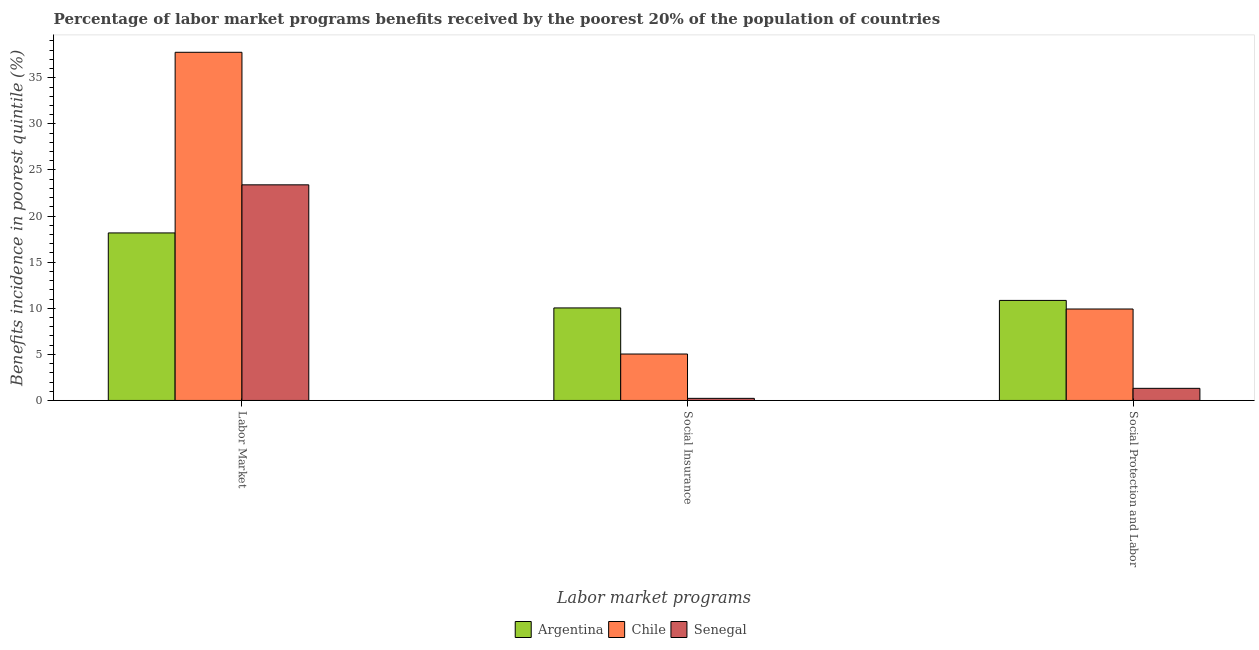How many groups of bars are there?
Provide a succinct answer. 3. Are the number of bars per tick equal to the number of legend labels?
Offer a terse response. Yes. Are the number of bars on each tick of the X-axis equal?
Offer a terse response. Yes. What is the label of the 2nd group of bars from the left?
Offer a very short reply. Social Insurance. What is the percentage of benefits received due to social protection programs in Senegal?
Keep it short and to the point. 1.31. Across all countries, what is the maximum percentage of benefits received due to social insurance programs?
Give a very brief answer. 10.04. Across all countries, what is the minimum percentage of benefits received due to social insurance programs?
Offer a terse response. 0.23. In which country was the percentage of benefits received due to social protection programs minimum?
Give a very brief answer. Senegal. What is the total percentage of benefits received due to labor market programs in the graph?
Make the answer very short. 79.33. What is the difference between the percentage of benefits received due to labor market programs in Senegal and that in Chile?
Your answer should be compact. -14.38. What is the difference between the percentage of benefits received due to labor market programs in Chile and the percentage of benefits received due to social protection programs in Senegal?
Make the answer very short. 36.45. What is the average percentage of benefits received due to social insurance programs per country?
Give a very brief answer. 5.1. What is the difference between the percentage of benefits received due to social protection programs and percentage of benefits received due to labor market programs in Argentina?
Provide a succinct answer. -7.32. What is the ratio of the percentage of benefits received due to social insurance programs in Senegal to that in Chile?
Your answer should be compact. 0.05. Is the percentage of benefits received due to social insurance programs in Senegal less than that in Argentina?
Provide a short and direct response. Yes. Is the difference between the percentage of benefits received due to social protection programs in Chile and Senegal greater than the difference between the percentage of benefits received due to labor market programs in Chile and Senegal?
Your answer should be very brief. No. What is the difference between the highest and the second highest percentage of benefits received due to social protection programs?
Your answer should be compact. 0.93. What is the difference between the highest and the lowest percentage of benefits received due to social insurance programs?
Offer a very short reply. 9.81. In how many countries, is the percentage of benefits received due to social protection programs greater than the average percentage of benefits received due to social protection programs taken over all countries?
Your answer should be very brief. 2. What does the 2nd bar from the left in Social Insurance represents?
Offer a very short reply. Chile. What does the 2nd bar from the right in Labor Market represents?
Offer a very short reply. Chile. Is it the case that in every country, the sum of the percentage of benefits received due to labor market programs and percentage of benefits received due to social insurance programs is greater than the percentage of benefits received due to social protection programs?
Your response must be concise. Yes. Are all the bars in the graph horizontal?
Provide a succinct answer. No. What is the difference between two consecutive major ticks on the Y-axis?
Your response must be concise. 5. Are the values on the major ticks of Y-axis written in scientific E-notation?
Ensure brevity in your answer.  No. Does the graph contain any zero values?
Ensure brevity in your answer.  No. Does the graph contain grids?
Provide a short and direct response. No. How many legend labels are there?
Give a very brief answer. 3. How are the legend labels stacked?
Your response must be concise. Horizontal. What is the title of the graph?
Give a very brief answer. Percentage of labor market programs benefits received by the poorest 20% of the population of countries. What is the label or title of the X-axis?
Offer a terse response. Labor market programs. What is the label or title of the Y-axis?
Keep it short and to the point. Benefits incidence in poorest quintile (%). What is the Benefits incidence in poorest quintile (%) of Argentina in Labor Market?
Offer a terse response. 18.17. What is the Benefits incidence in poorest quintile (%) of Chile in Labor Market?
Provide a succinct answer. 37.77. What is the Benefits incidence in poorest quintile (%) in Senegal in Labor Market?
Offer a very short reply. 23.39. What is the Benefits incidence in poorest quintile (%) in Argentina in Social Insurance?
Keep it short and to the point. 10.04. What is the Benefits incidence in poorest quintile (%) of Chile in Social Insurance?
Provide a short and direct response. 5.04. What is the Benefits incidence in poorest quintile (%) in Senegal in Social Insurance?
Keep it short and to the point. 0.23. What is the Benefits incidence in poorest quintile (%) in Argentina in Social Protection and Labor?
Provide a short and direct response. 10.85. What is the Benefits incidence in poorest quintile (%) in Chile in Social Protection and Labor?
Offer a terse response. 9.92. What is the Benefits incidence in poorest quintile (%) in Senegal in Social Protection and Labor?
Give a very brief answer. 1.31. Across all Labor market programs, what is the maximum Benefits incidence in poorest quintile (%) of Argentina?
Your answer should be compact. 18.17. Across all Labor market programs, what is the maximum Benefits incidence in poorest quintile (%) of Chile?
Provide a short and direct response. 37.77. Across all Labor market programs, what is the maximum Benefits incidence in poorest quintile (%) in Senegal?
Offer a very short reply. 23.39. Across all Labor market programs, what is the minimum Benefits incidence in poorest quintile (%) in Argentina?
Ensure brevity in your answer.  10.04. Across all Labor market programs, what is the minimum Benefits incidence in poorest quintile (%) in Chile?
Ensure brevity in your answer.  5.04. Across all Labor market programs, what is the minimum Benefits incidence in poorest quintile (%) in Senegal?
Offer a very short reply. 0.23. What is the total Benefits incidence in poorest quintile (%) of Argentina in the graph?
Give a very brief answer. 39.06. What is the total Benefits incidence in poorest quintile (%) in Chile in the graph?
Your answer should be very brief. 52.72. What is the total Benefits incidence in poorest quintile (%) of Senegal in the graph?
Your answer should be very brief. 24.93. What is the difference between the Benefits incidence in poorest quintile (%) of Argentina in Labor Market and that in Social Insurance?
Make the answer very short. 8.14. What is the difference between the Benefits incidence in poorest quintile (%) in Chile in Labor Market and that in Social Insurance?
Your response must be concise. 32.73. What is the difference between the Benefits incidence in poorest quintile (%) in Senegal in Labor Market and that in Social Insurance?
Keep it short and to the point. 23.16. What is the difference between the Benefits incidence in poorest quintile (%) of Argentina in Labor Market and that in Social Protection and Labor?
Offer a terse response. 7.32. What is the difference between the Benefits incidence in poorest quintile (%) in Chile in Labor Market and that in Social Protection and Labor?
Your answer should be compact. 27.85. What is the difference between the Benefits incidence in poorest quintile (%) of Senegal in Labor Market and that in Social Protection and Labor?
Your response must be concise. 22.07. What is the difference between the Benefits incidence in poorest quintile (%) in Argentina in Social Insurance and that in Social Protection and Labor?
Offer a very short reply. -0.81. What is the difference between the Benefits incidence in poorest quintile (%) in Chile in Social Insurance and that in Social Protection and Labor?
Your answer should be very brief. -4.88. What is the difference between the Benefits incidence in poorest quintile (%) in Senegal in Social Insurance and that in Social Protection and Labor?
Provide a succinct answer. -1.09. What is the difference between the Benefits incidence in poorest quintile (%) in Argentina in Labor Market and the Benefits incidence in poorest quintile (%) in Chile in Social Insurance?
Make the answer very short. 13.14. What is the difference between the Benefits incidence in poorest quintile (%) of Argentina in Labor Market and the Benefits incidence in poorest quintile (%) of Senegal in Social Insurance?
Give a very brief answer. 17.95. What is the difference between the Benefits incidence in poorest quintile (%) of Chile in Labor Market and the Benefits incidence in poorest quintile (%) of Senegal in Social Insurance?
Give a very brief answer. 37.54. What is the difference between the Benefits incidence in poorest quintile (%) of Argentina in Labor Market and the Benefits incidence in poorest quintile (%) of Chile in Social Protection and Labor?
Your answer should be very brief. 8.25. What is the difference between the Benefits incidence in poorest quintile (%) in Argentina in Labor Market and the Benefits incidence in poorest quintile (%) in Senegal in Social Protection and Labor?
Your answer should be compact. 16.86. What is the difference between the Benefits incidence in poorest quintile (%) of Chile in Labor Market and the Benefits incidence in poorest quintile (%) of Senegal in Social Protection and Labor?
Make the answer very short. 36.45. What is the difference between the Benefits incidence in poorest quintile (%) of Argentina in Social Insurance and the Benefits incidence in poorest quintile (%) of Chile in Social Protection and Labor?
Your response must be concise. 0.12. What is the difference between the Benefits incidence in poorest quintile (%) of Argentina in Social Insurance and the Benefits incidence in poorest quintile (%) of Senegal in Social Protection and Labor?
Your response must be concise. 8.72. What is the difference between the Benefits incidence in poorest quintile (%) in Chile in Social Insurance and the Benefits incidence in poorest quintile (%) in Senegal in Social Protection and Labor?
Provide a succinct answer. 3.72. What is the average Benefits incidence in poorest quintile (%) of Argentina per Labor market programs?
Make the answer very short. 13.02. What is the average Benefits incidence in poorest quintile (%) in Chile per Labor market programs?
Offer a terse response. 17.57. What is the average Benefits incidence in poorest quintile (%) of Senegal per Labor market programs?
Keep it short and to the point. 8.31. What is the difference between the Benefits incidence in poorest quintile (%) in Argentina and Benefits incidence in poorest quintile (%) in Chile in Labor Market?
Your answer should be compact. -19.6. What is the difference between the Benefits incidence in poorest quintile (%) of Argentina and Benefits incidence in poorest quintile (%) of Senegal in Labor Market?
Offer a very short reply. -5.22. What is the difference between the Benefits incidence in poorest quintile (%) of Chile and Benefits incidence in poorest quintile (%) of Senegal in Labor Market?
Make the answer very short. 14.38. What is the difference between the Benefits incidence in poorest quintile (%) of Argentina and Benefits incidence in poorest quintile (%) of Chile in Social Insurance?
Your answer should be compact. 5. What is the difference between the Benefits incidence in poorest quintile (%) in Argentina and Benefits incidence in poorest quintile (%) in Senegal in Social Insurance?
Offer a very short reply. 9.81. What is the difference between the Benefits incidence in poorest quintile (%) in Chile and Benefits incidence in poorest quintile (%) in Senegal in Social Insurance?
Make the answer very short. 4.81. What is the difference between the Benefits incidence in poorest quintile (%) in Argentina and Benefits incidence in poorest quintile (%) in Chile in Social Protection and Labor?
Give a very brief answer. 0.93. What is the difference between the Benefits incidence in poorest quintile (%) of Argentina and Benefits incidence in poorest quintile (%) of Senegal in Social Protection and Labor?
Your answer should be very brief. 9.54. What is the difference between the Benefits incidence in poorest quintile (%) of Chile and Benefits incidence in poorest quintile (%) of Senegal in Social Protection and Labor?
Your answer should be very brief. 8.61. What is the ratio of the Benefits incidence in poorest quintile (%) of Argentina in Labor Market to that in Social Insurance?
Provide a short and direct response. 1.81. What is the ratio of the Benefits incidence in poorest quintile (%) in Chile in Labor Market to that in Social Insurance?
Provide a succinct answer. 7.5. What is the ratio of the Benefits incidence in poorest quintile (%) of Senegal in Labor Market to that in Social Insurance?
Your answer should be very brief. 102.83. What is the ratio of the Benefits incidence in poorest quintile (%) in Argentina in Labor Market to that in Social Protection and Labor?
Provide a short and direct response. 1.67. What is the ratio of the Benefits incidence in poorest quintile (%) of Chile in Labor Market to that in Social Protection and Labor?
Offer a terse response. 3.81. What is the ratio of the Benefits incidence in poorest quintile (%) of Senegal in Labor Market to that in Social Protection and Labor?
Give a very brief answer. 17.8. What is the ratio of the Benefits incidence in poorest quintile (%) in Argentina in Social Insurance to that in Social Protection and Labor?
Make the answer very short. 0.93. What is the ratio of the Benefits incidence in poorest quintile (%) in Chile in Social Insurance to that in Social Protection and Labor?
Provide a short and direct response. 0.51. What is the ratio of the Benefits incidence in poorest quintile (%) of Senegal in Social Insurance to that in Social Protection and Labor?
Keep it short and to the point. 0.17. What is the difference between the highest and the second highest Benefits incidence in poorest quintile (%) in Argentina?
Make the answer very short. 7.32. What is the difference between the highest and the second highest Benefits incidence in poorest quintile (%) in Chile?
Your response must be concise. 27.85. What is the difference between the highest and the second highest Benefits incidence in poorest quintile (%) in Senegal?
Provide a short and direct response. 22.07. What is the difference between the highest and the lowest Benefits incidence in poorest quintile (%) in Argentina?
Your answer should be compact. 8.14. What is the difference between the highest and the lowest Benefits incidence in poorest quintile (%) in Chile?
Keep it short and to the point. 32.73. What is the difference between the highest and the lowest Benefits incidence in poorest quintile (%) of Senegal?
Offer a very short reply. 23.16. 